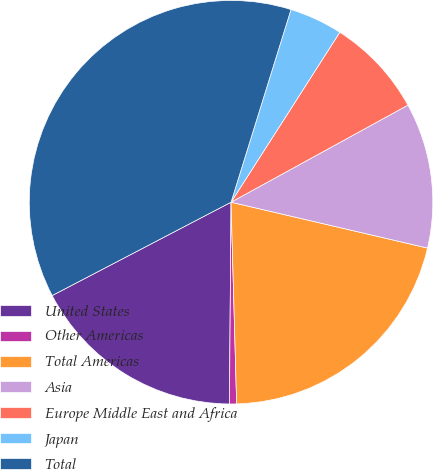Convert chart. <chart><loc_0><loc_0><loc_500><loc_500><pie_chart><fcel>United States<fcel>Other Americas<fcel>Total Americas<fcel>Asia<fcel>Europe Middle East and Africa<fcel>Japan<fcel>Total<nl><fcel>17.22%<fcel>0.57%<fcel>20.91%<fcel>11.64%<fcel>7.95%<fcel>4.26%<fcel>37.46%<nl></chart> 